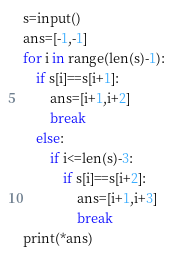Convert code to text. <code><loc_0><loc_0><loc_500><loc_500><_Python_>s=input()
ans=[-1,-1]
for i in range(len(s)-1):
    if s[i]==s[i+1]:
        ans=[i+1,i+2]
        break
    else:
        if i<=len(s)-3:
            if s[i]==s[i+2]:
                ans=[i+1,i+3]
                break
print(*ans)</code> 